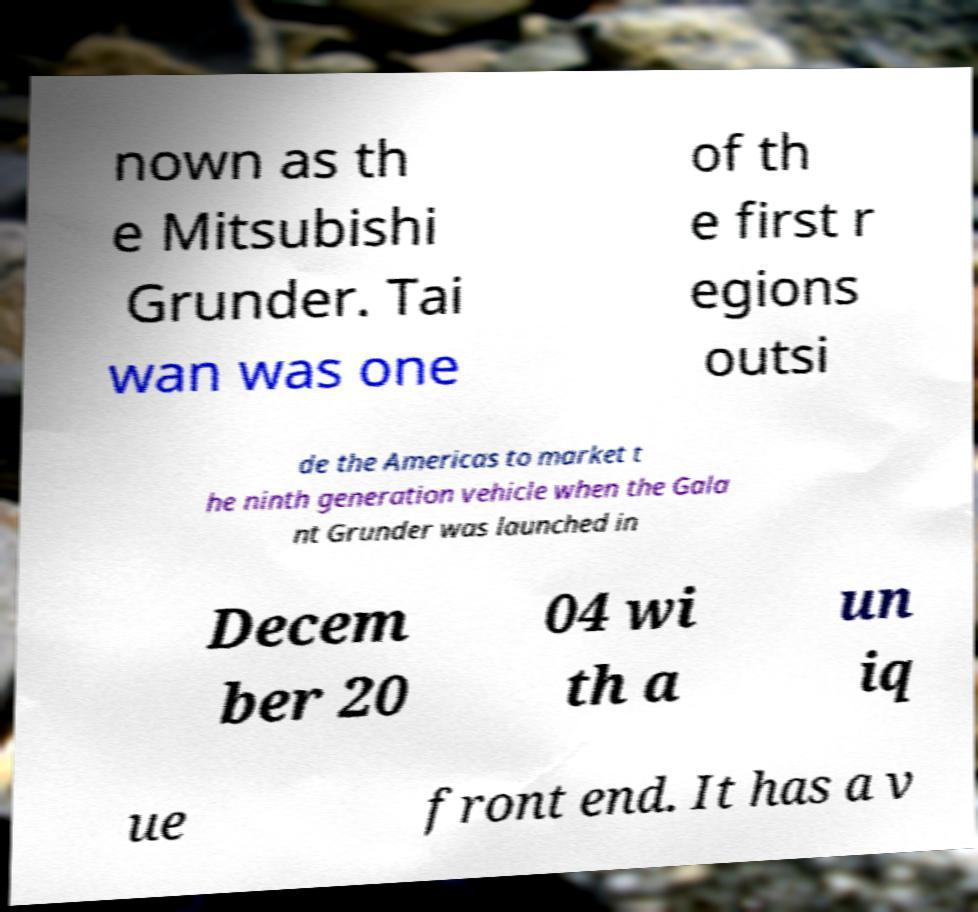What messages or text are displayed in this image? I need them in a readable, typed format. nown as th e Mitsubishi Grunder. Tai wan was one of th e first r egions outsi de the Americas to market t he ninth generation vehicle when the Gala nt Grunder was launched in Decem ber 20 04 wi th a un iq ue front end. It has a v 